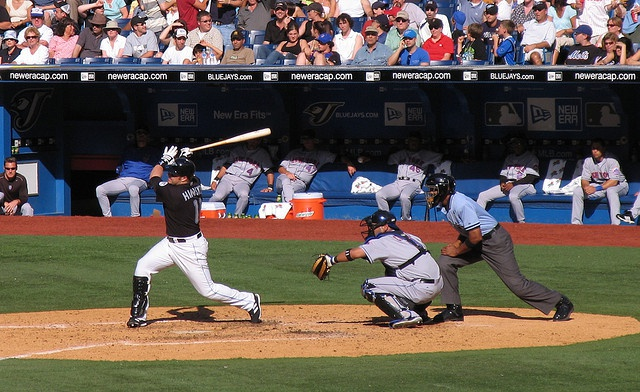Describe the objects in this image and their specific colors. I can see people in maroon, black, lavender, gray, and darkgray tones, people in maroon, black, gray, and darkgray tones, people in maroon, lavender, black, darkgray, and gray tones, people in maroon, black, darkgray, lavender, and blue tones, and bench in maroon, blue, navy, darkblue, and white tones in this image. 